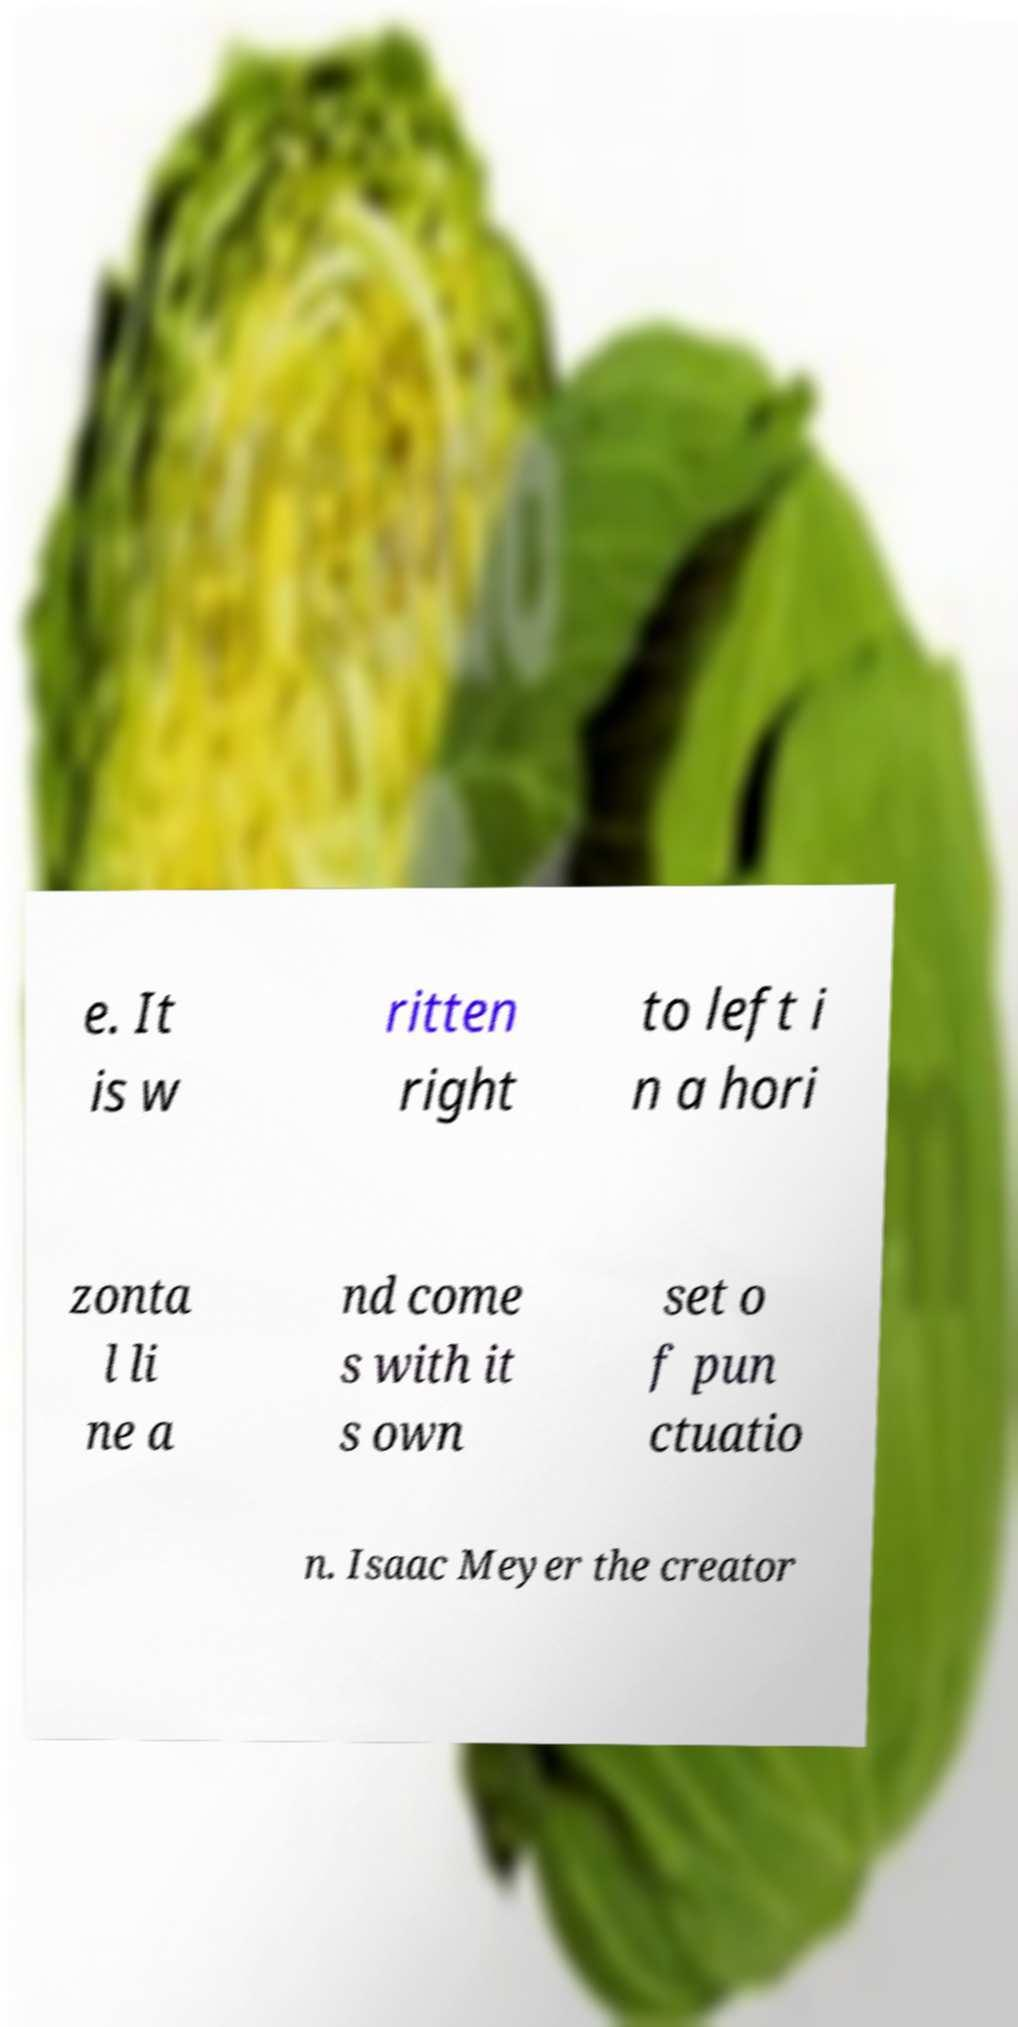Could you extract and type out the text from this image? e. It is w ritten right to left i n a hori zonta l li ne a nd come s with it s own set o f pun ctuatio n. Isaac Meyer the creator 